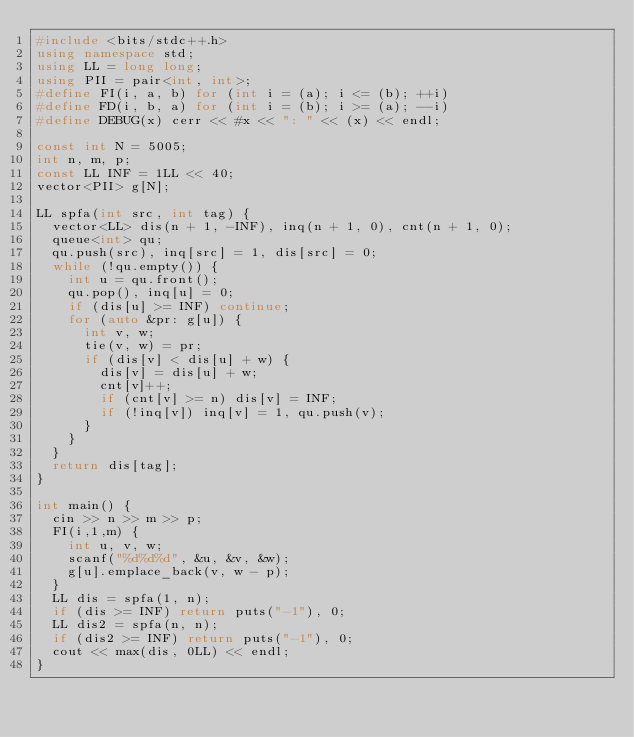Convert code to text. <code><loc_0><loc_0><loc_500><loc_500><_C++_>#include <bits/stdc++.h>
using namespace std;
using LL = long long;
using PII = pair<int, int>;
#define FI(i, a, b) for (int i = (a); i <= (b); ++i)
#define FD(i, b, a) for (int i = (b); i >= (a); --i)
#define DEBUG(x) cerr << #x << ": " << (x) << endl;

const int N = 5005;
int n, m, p;
const LL INF = 1LL << 40;
vector<PII> g[N];

LL spfa(int src, int tag) {
  vector<LL> dis(n + 1, -INF), inq(n + 1, 0), cnt(n + 1, 0);
  queue<int> qu;
  qu.push(src), inq[src] = 1, dis[src] = 0;
  while (!qu.empty()) {
    int u = qu.front();
    qu.pop(), inq[u] = 0;
    if (dis[u] >= INF) continue;
    for (auto &pr: g[u]) {
      int v, w;
      tie(v, w) = pr;
      if (dis[v] < dis[u] + w) {
        dis[v] = dis[u] + w;
        cnt[v]++;
        if (cnt[v] >= n) dis[v] = INF;
        if (!inq[v]) inq[v] = 1, qu.push(v);
      }
    }
  }
  return dis[tag];
}

int main() {
  cin >> n >> m >> p;
  FI(i,1,m) {
    int u, v, w;
    scanf("%d%d%d", &u, &v, &w);
    g[u].emplace_back(v, w - p);
  }
  LL dis = spfa(1, n);
  if (dis >= INF) return puts("-1"), 0;
  LL dis2 = spfa(n, n);
  if (dis2 >= INF) return puts("-1"), 0;
  cout << max(dis, 0LL) << endl;
}
</code> 